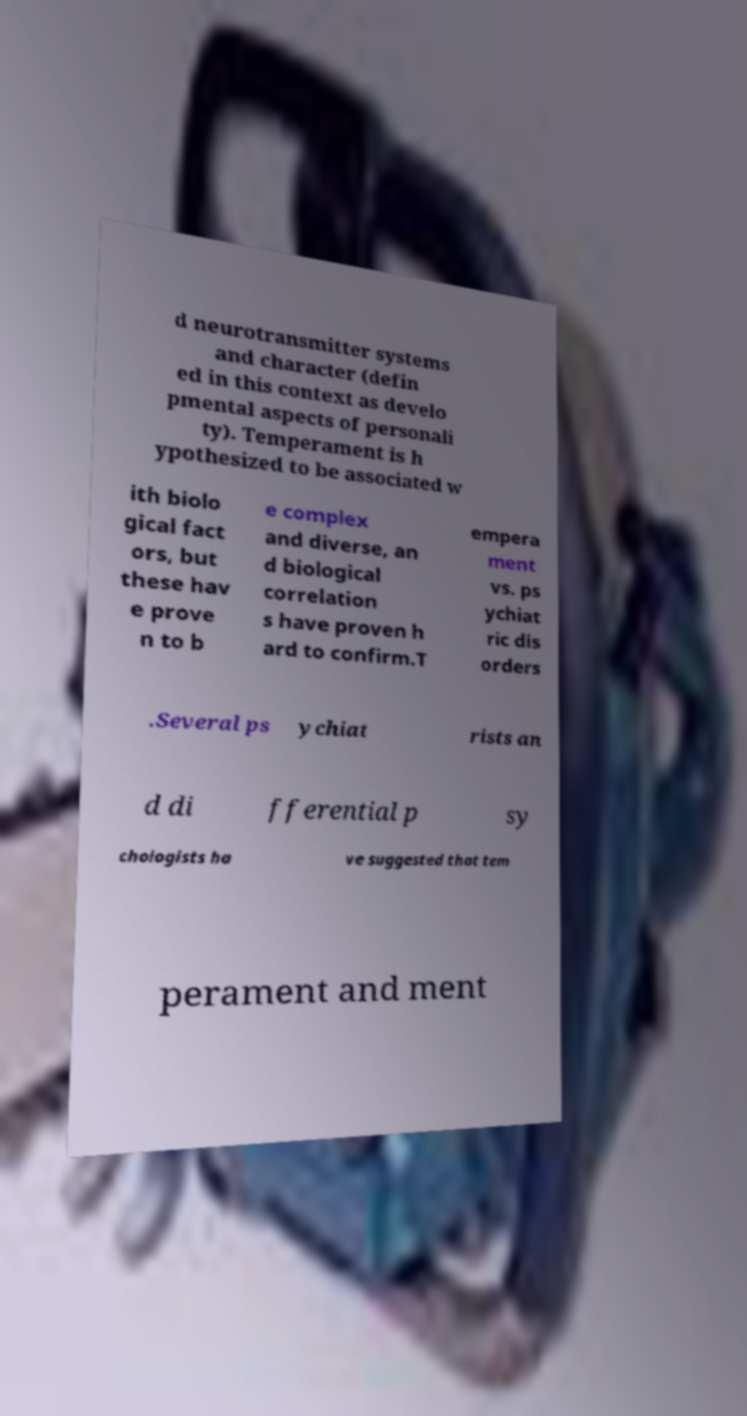Can you accurately transcribe the text from the provided image for me? d neurotransmitter systems and character (defin ed in this context as develo pmental aspects of personali ty). Temperament is h ypothesized to be associated w ith biolo gical fact ors, but these hav e prove n to b e complex and diverse, an d biological correlation s have proven h ard to confirm.T empera ment vs. ps ychiat ric dis orders .Several ps ychiat rists an d di fferential p sy chologists ha ve suggested that tem perament and ment 